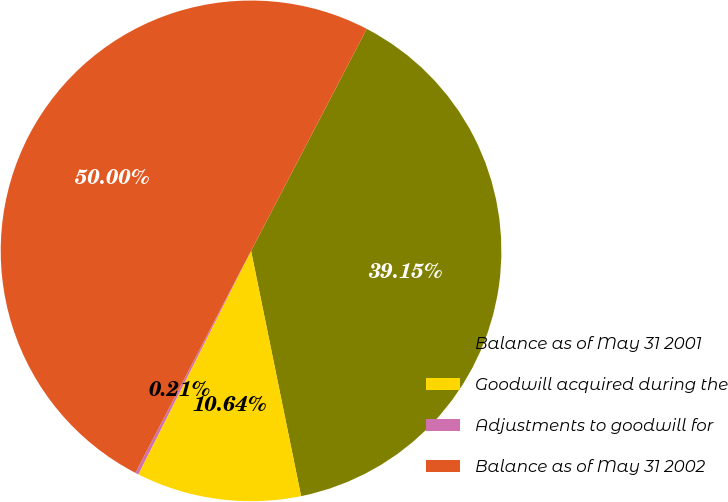Convert chart to OTSL. <chart><loc_0><loc_0><loc_500><loc_500><pie_chart><fcel>Balance as of May 31 2001<fcel>Goodwill acquired during the<fcel>Adjustments to goodwill for<fcel>Balance as of May 31 2002<nl><fcel>39.15%<fcel>10.64%<fcel>0.21%<fcel>50.0%<nl></chart> 